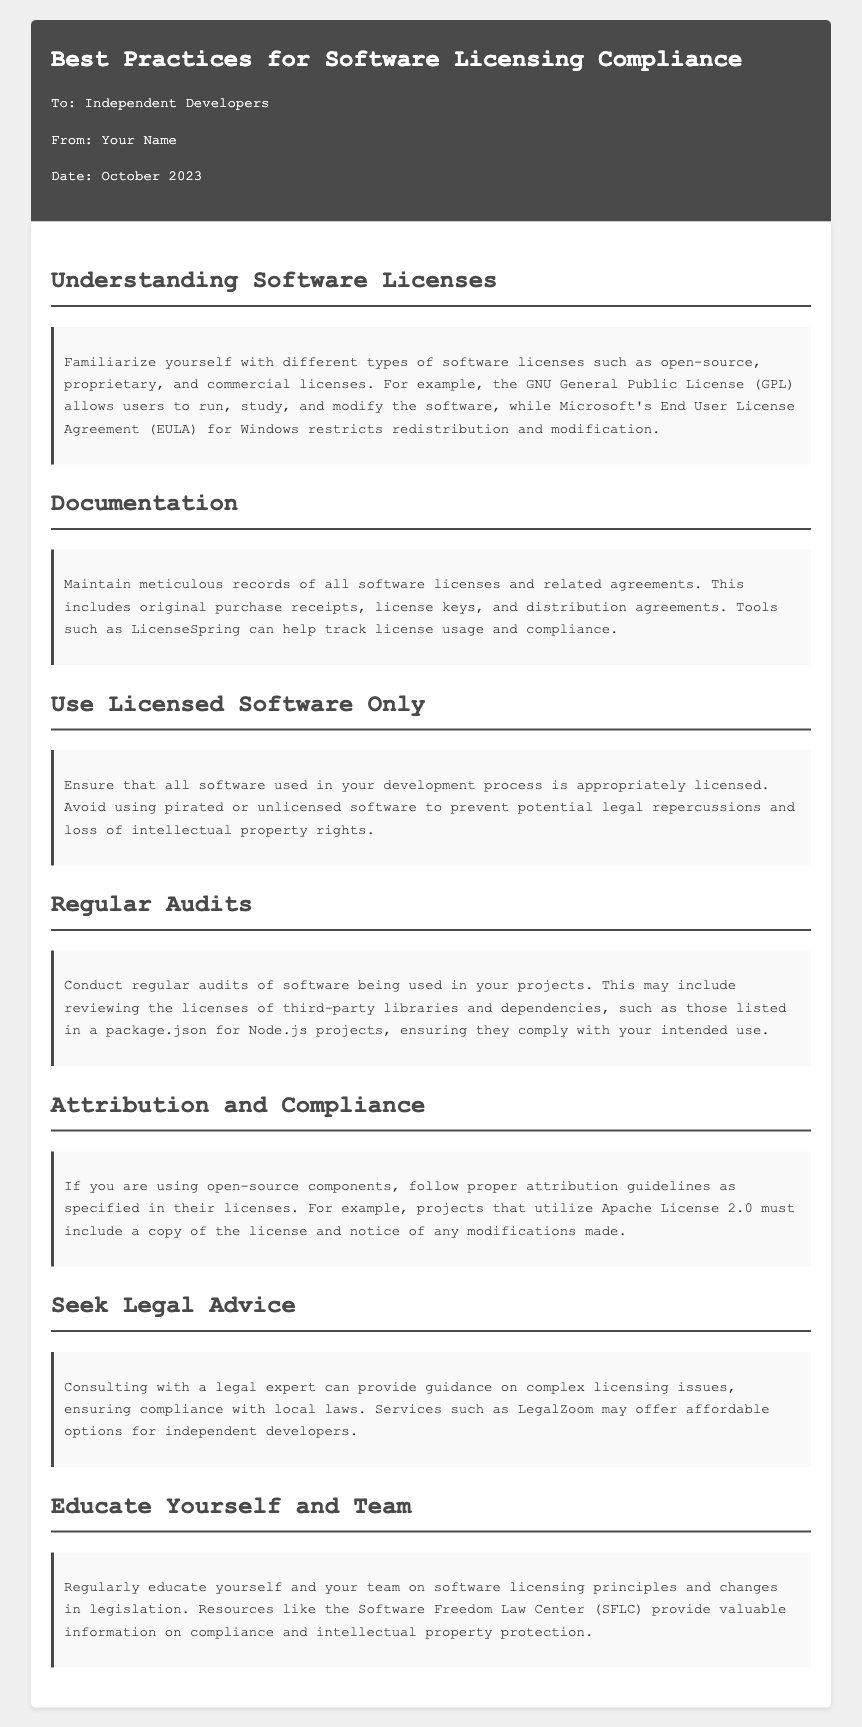What is the date of the memo? The date stated in the memo is when the information is provided, which is October 2023.
Answer: October 2023 Who is the target audience of the memo? The intended recipients of the memo are specified in the opening section, referring to them as independent developers.
Answer: Independent Developers What does the GPL allow users to do? The memo describes that the GNU General Public License allows users to run, study, and modify the software.
Answer: Run, study, and modify What should be maintained according to the documentation section? The memo emphasizes the importance of keeping accurate records of software licenses and related agreements.
Answer: Records of software licenses What can LicenseSpring help with? The document states that LicenseSpring can assist in tracking license usage and compliance.
Answer: Tracking license usage and compliance What is a recommended tool for regular audits? The document suggests reviewing the licenses of third-party libraries and dependencies as part of regular audits.
Answer: Reviewing licenses What should be included with Apache License 2.0 components? It is stated that a copy of the license and notice of any modifications made must be included with Apache License 2.0 components.
Answer: A copy of the license and notice of modifications Why is consulting with a legal expert advised? The memo highlights that legal advice can provide guidance on complex licensing issues, ensuring compliance.
Answer: Providing guidance on complex licensing issues Which organization is mentioned for resources on compliance? The document references the Software Freedom Law Center as a source of information on compliance and intellectual property protection.
Answer: Software Freedom Law Center 